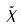<formula> <loc_0><loc_0><loc_500><loc_500>\tilde { X }</formula> 